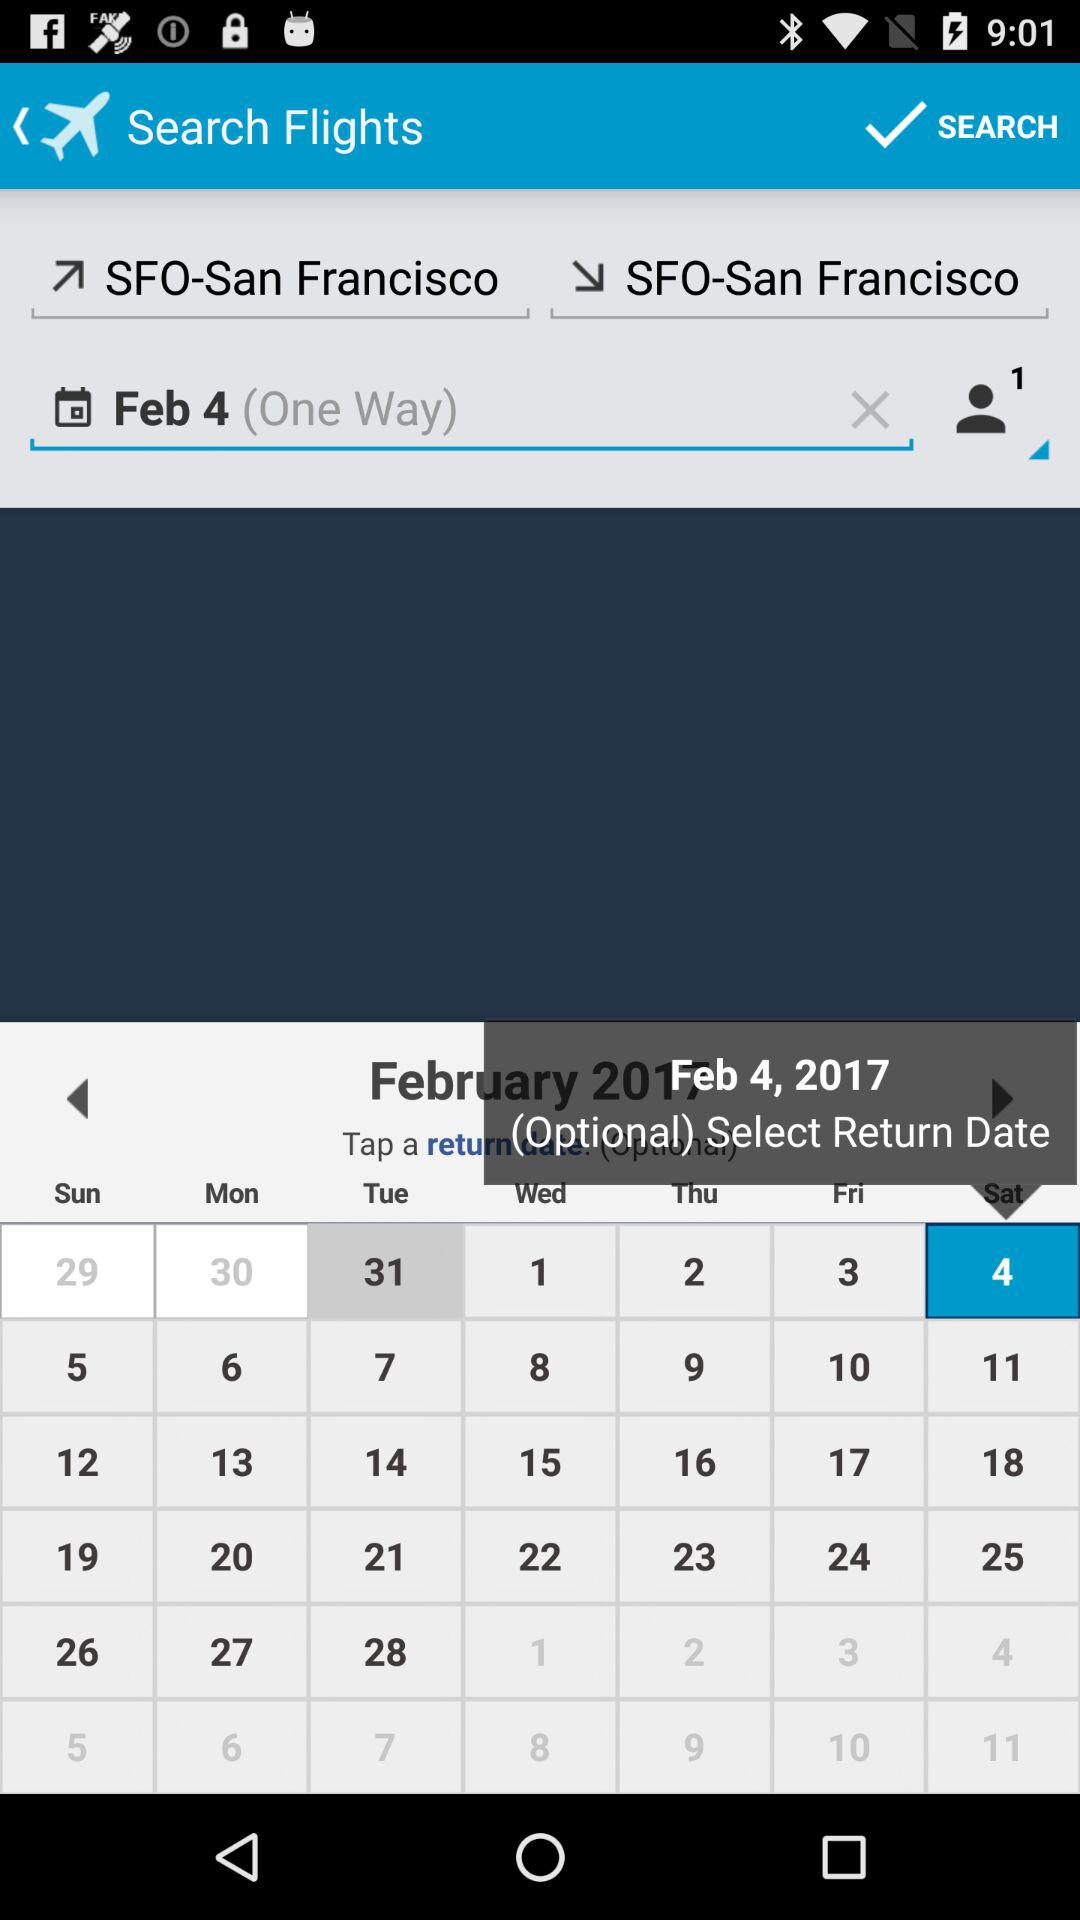How many passengers are there? There is 1 passenger. 